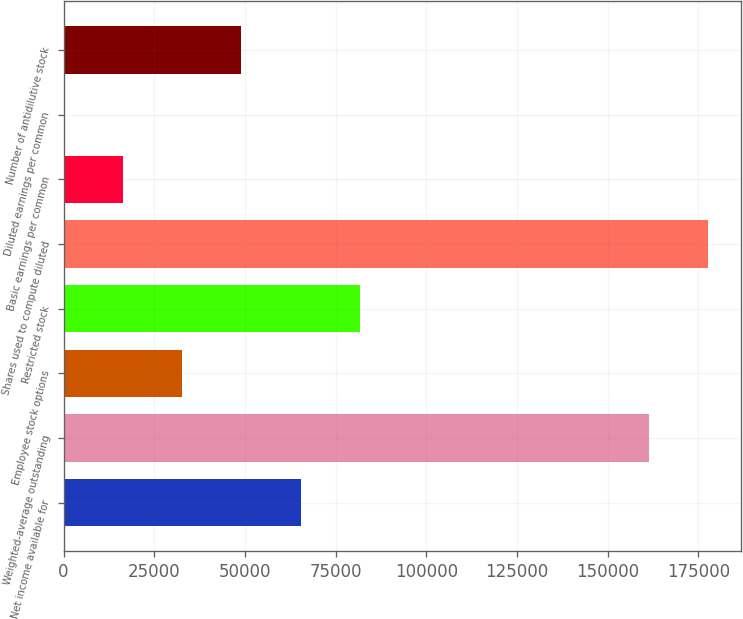<chart> <loc_0><loc_0><loc_500><loc_500><bar_chart><fcel>Net income available for<fcel>Weighted-average outstanding<fcel>Employee stock options<fcel>Restricted stock<fcel>Shares used to compute diluted<fcel>Basic earnings per common<fcel>Diluted earnings per common<fcel>Number of antidilutive stock<nl><fcel>65387.3<fcel>161484<fcel>32697.4<fcel>81732.2<fcel>177829<fcel>16352.4<fcel>7.47<fcel>49042.3<nl></chart> 